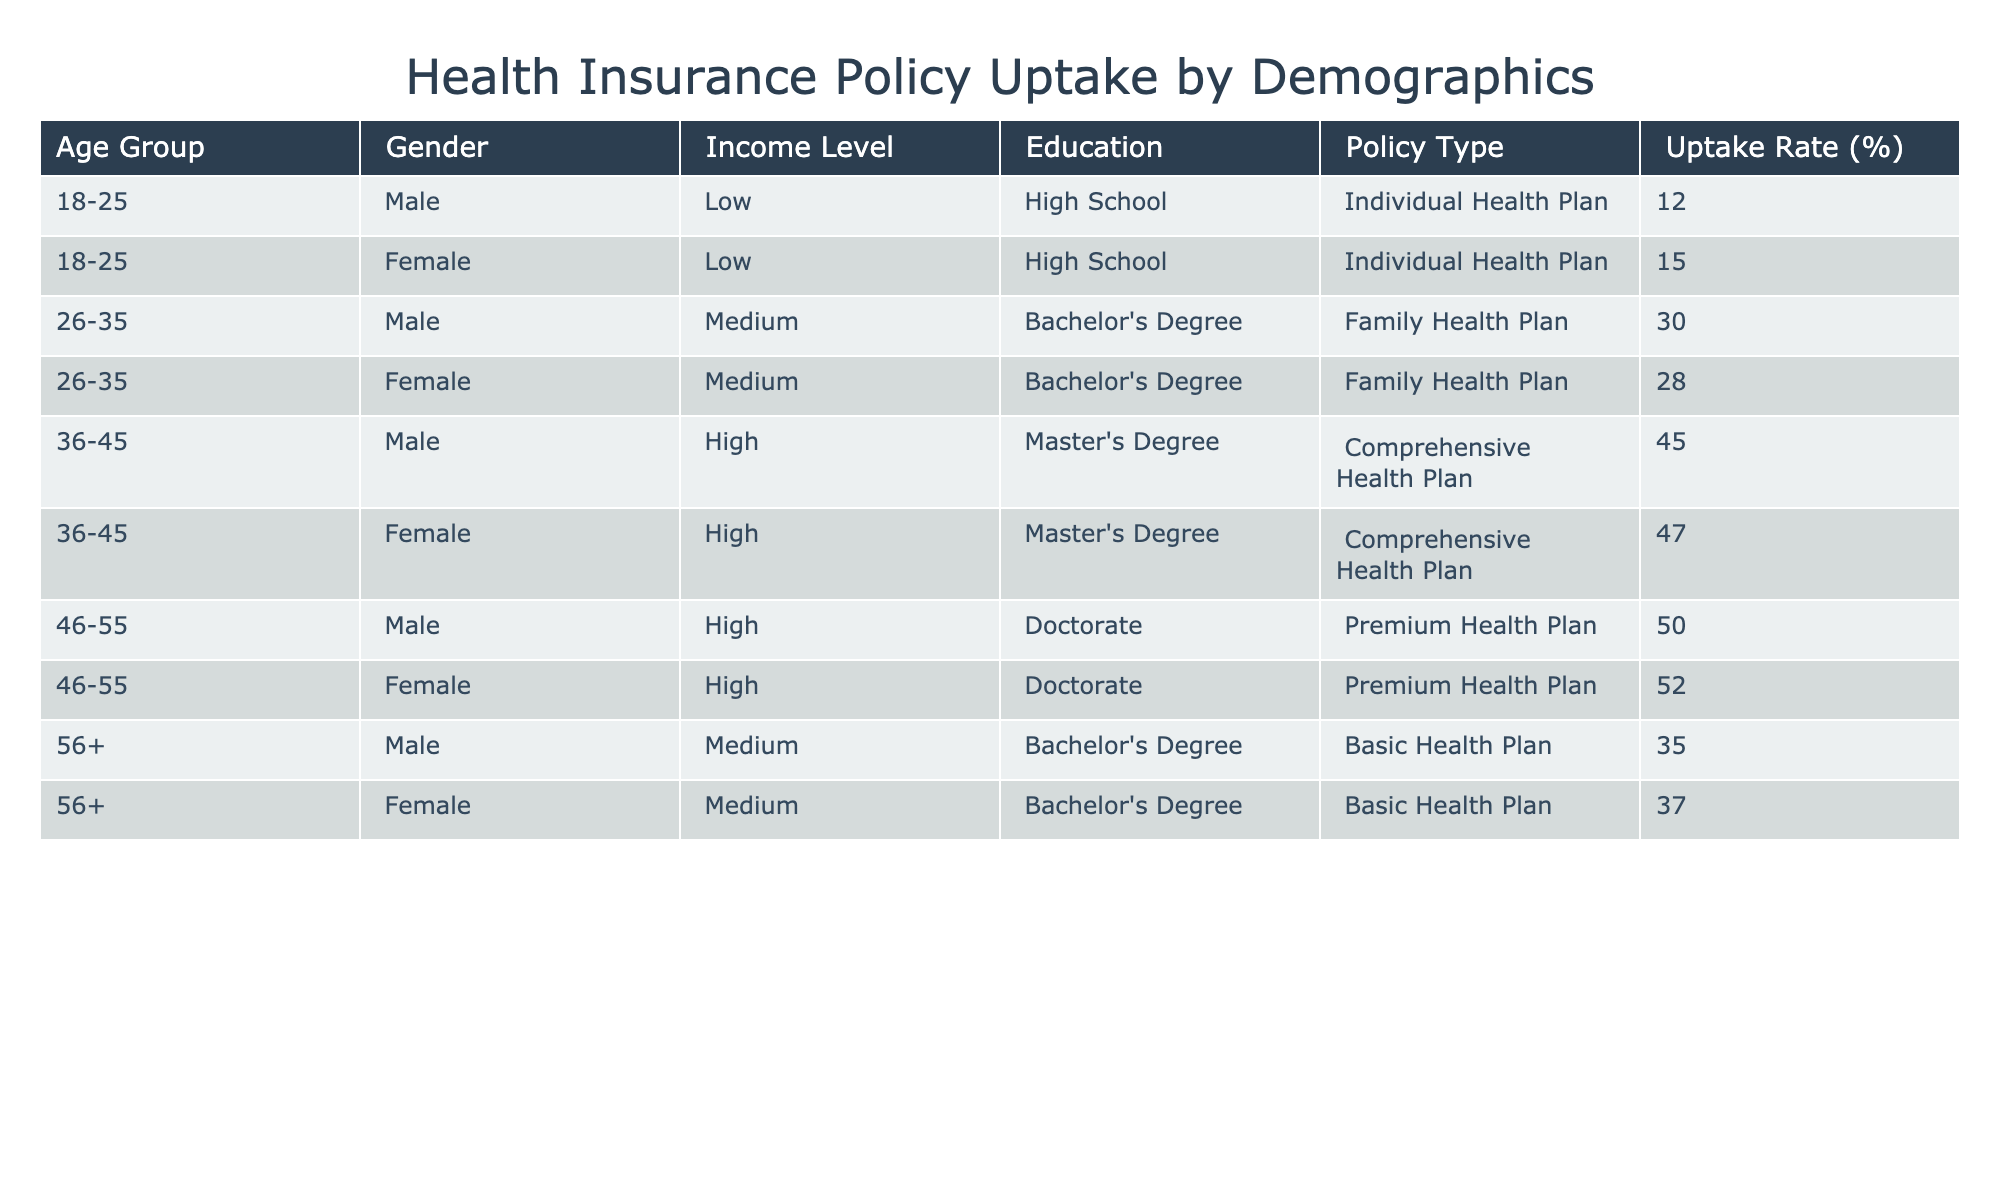What is the uptake rate for Female customers aged 18-25 for Individual Health Plans? From the table, I can see that the uptake rate for Female customers within that age group and policy type is listed as 15%.
Answer: 15% Which age group has the highest uptake rate for Health Plans? Looking through the data, the 46-55 age group has the highest uptake rate of 50% for males and 52% for females, making it the highest overall.
Answer: 52% What is the average uptake rate for Family Health Plans across both genders in the 26-35 age group? The uptake rates for Family Health Plans in the 26-35 age group are 30% for males and 28% for females. The average is (30 + 28) / 2 = 29%.
Answer: 29% Is the uptake rate for the Basic Health Plan higher for Females than Males in the 56+ age group? The table shows an uptake rate of 37% for Females and 35% for Males in the 56+ age group. Since 37% is greater than 35%, the answer is yes.
Answer: Yes What is the difference in uptake rates between Comprehensive and Premium Health Plans for the 36-45 age group? For the Comprehensive Health Plan, the rates are 45% for Males and 47% for Females, with an average of (45 + 47) / 2 = 46%. For the Premium Health Plan, the average rate is (50 + 52) / 2 = 51%. The difference is 51 - 46 = 5%.
Answer: 5% 